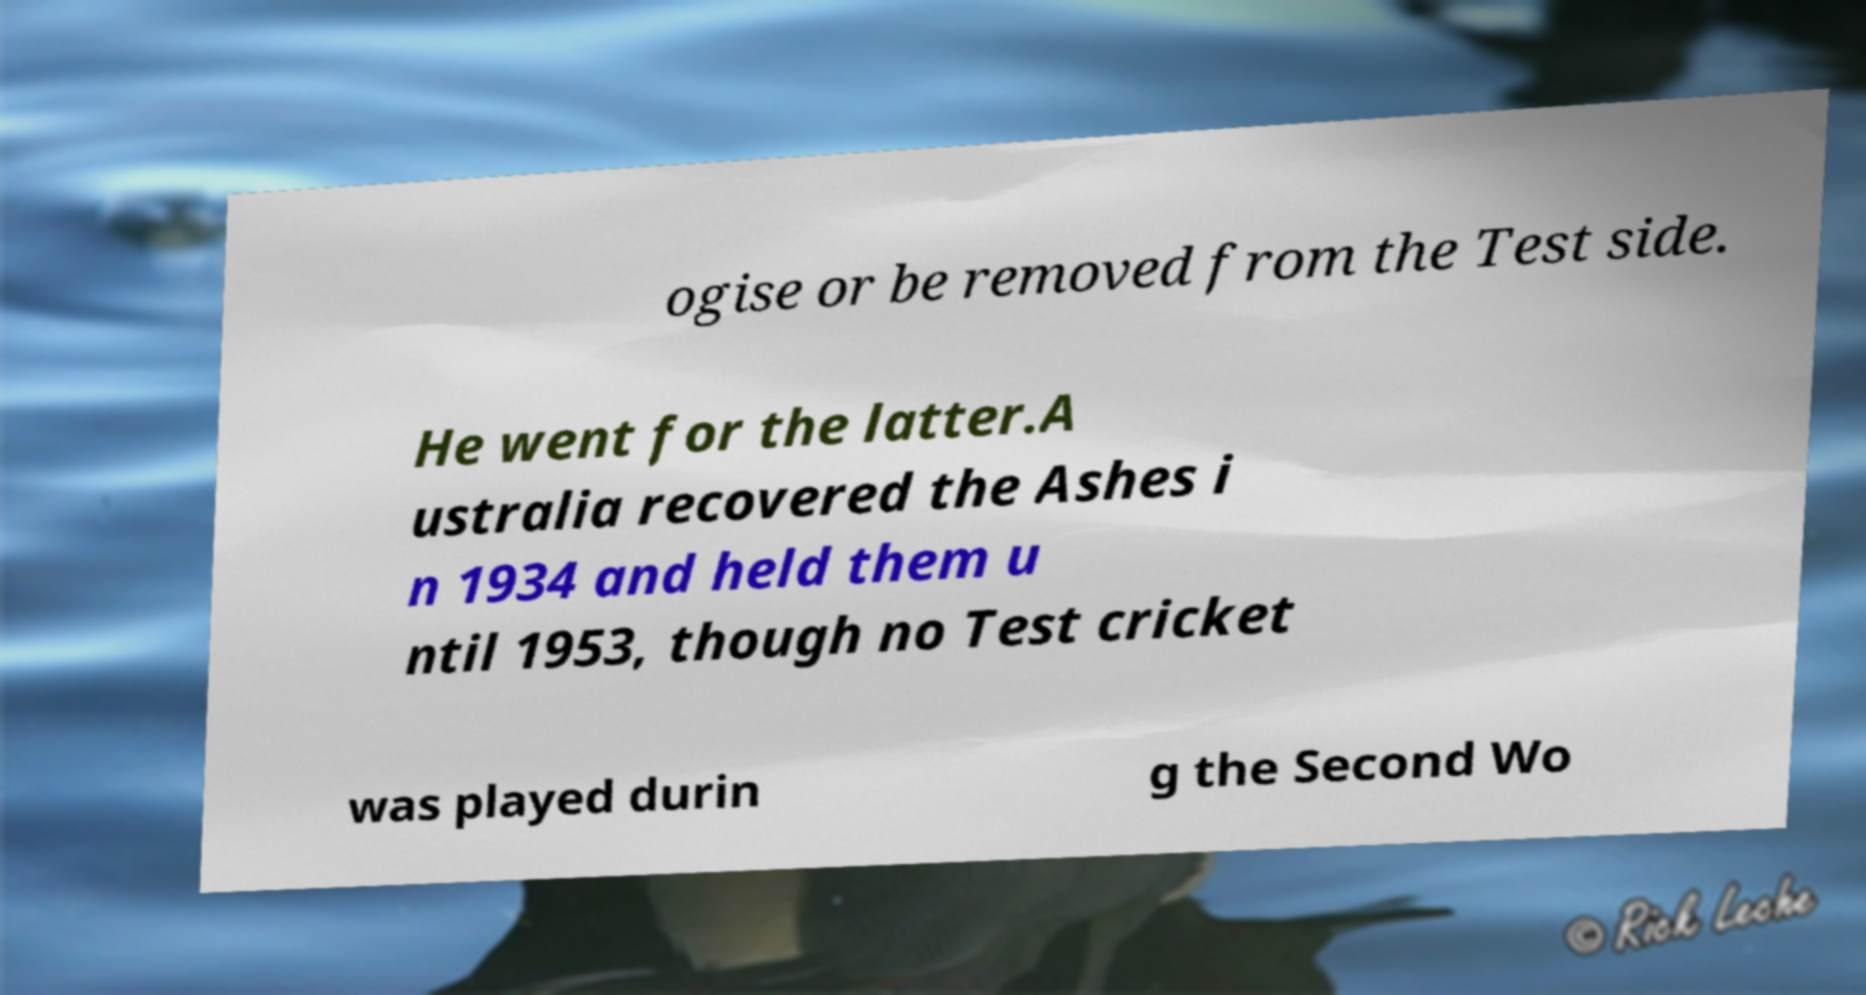Please identify and transcribe the text found in this image. ogise or be removed from the Test side. He went for the latter.A ustralia recovered the Ashes i n 1934 and held them u ntil 1953, though no Test cricket was played durin g the Second Wo 